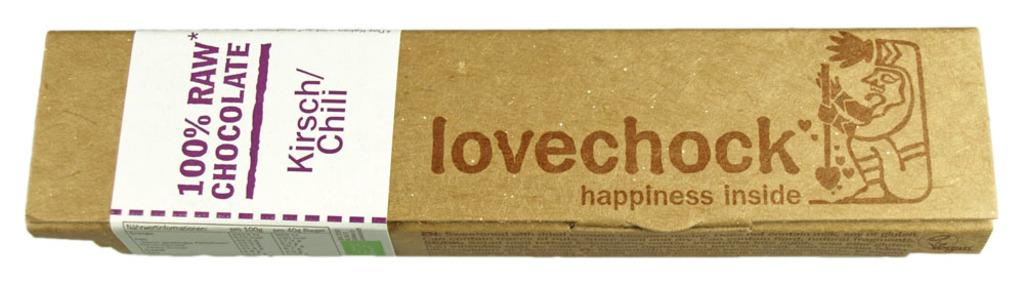<image>
Provide a brief description of the given image. A box with a label reading 100% raw chocolate with the words lovechock happiness inside printed on the box. 